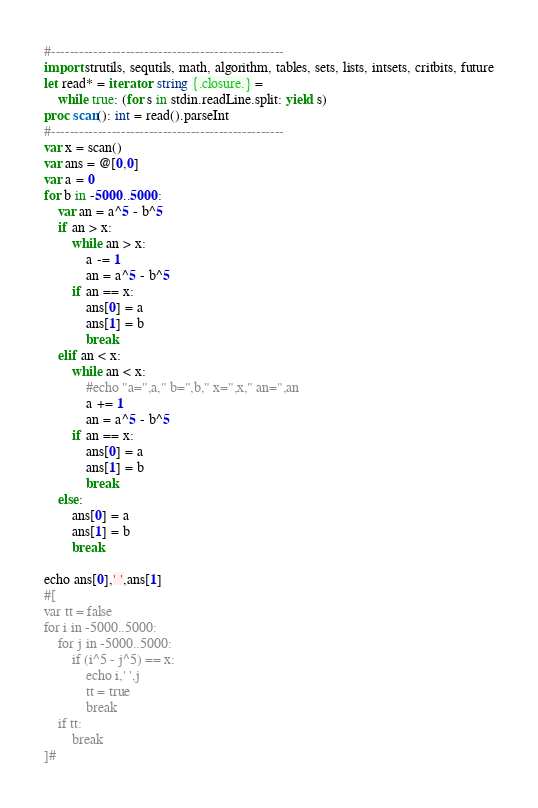Convert code to text. <code><loc_0><loc_0><loc_500><loc_500><_Nim_>#--------------------------------------------------
import strutils, sequtils, math, algorithm, tables, sets, lists, intsets, critbits, future
let read* = iterator: string {.closure.} =
    while true: (for s in stdin.readLine.split: yield s)
proc scan(): int = read().parseInt
#--------------------------------------------------
var x = scan()
var ans = @[0,0]
var a = 0
for b in -5000..5000:
    var an = a^5 - b^5
    if an > x:
        while an > x:
            a -= 1
            an = a^5 - b^5
        if an == x:
            ans[0] = a
            ans[1] = b
            break
    elif an < x:
        while an < x:
            #echo "a=",a," b=",b," x=",x," an=",an
            a += 1
            an = a^5 - b^5
        if an == x:
            ans[0] = a
            ans[1] = b
            break
    else:
        ans[0] = a
        ans[1] = b
        break

echo ans[0],' ',ans[1]
#[
var tt = false
for i in -5000..5000:
    for j in -5000..5000:
        if (i^5 - j^5) == x:
            echo i,' ',j
            tt = true
            break
    if tt:
        break
]#</code> 